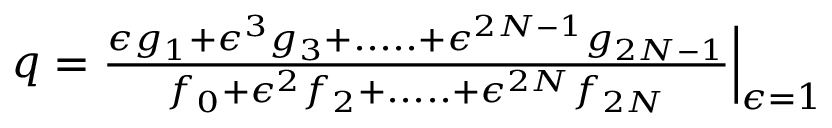<formula> <loc_0><loc_0><loc_500><loc_500>\begin{array} { r } { q = \frac { \epsilon g _ { 1 } + \epsilon ^ { 3 } g _ { 3 } + \cdots . + \epsilon ^ { 2 N - 1 } g _ { 2 N - 1 } } { f _ { 0 } + \epsilon ^ { 2 } f _ { 2 } + \cdots . + \epsilon ^ { 2 N } f _ { 2 N } } \Big | _ { \epsilon = 1 } } \end{array}</formula> 